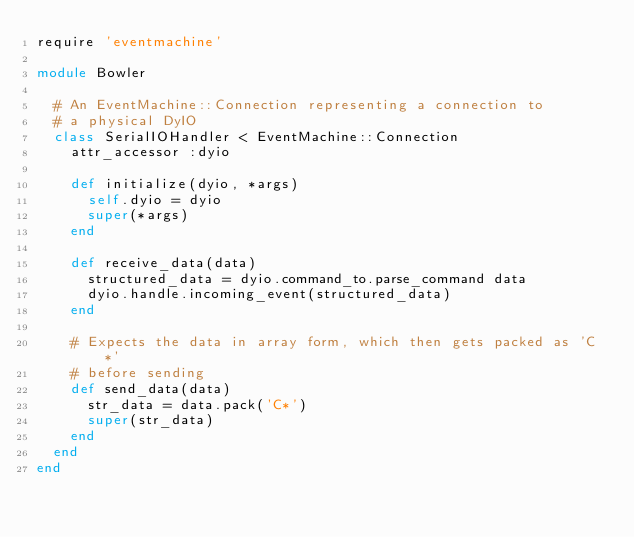Convert code to text. <code><loc_0><loc_0><loc_500><loc_500><_Ruby_>require 'eventmachine'

module Bowler

  # An EventMachine::Connection representing a connection to
  # a physical DyIO
  class SerialIOHandler < EventMachine::Connection
    attr_accessor :dyio

    def initialize(dyio, *args)
      self.dyio = dyio
      super(*args)
    end

    def receive_data(data)
      structured_data = dyio.command_to.parse_command data
      dyio.handle.incoming_event(structured_data)
    end

    # Expects the data in array form, which then gets packed as 'C*'
    # before sending
    def send_data(data)
      str_data = data.pack('C*')
      super(str_data)
    end
  end
end
</code> 